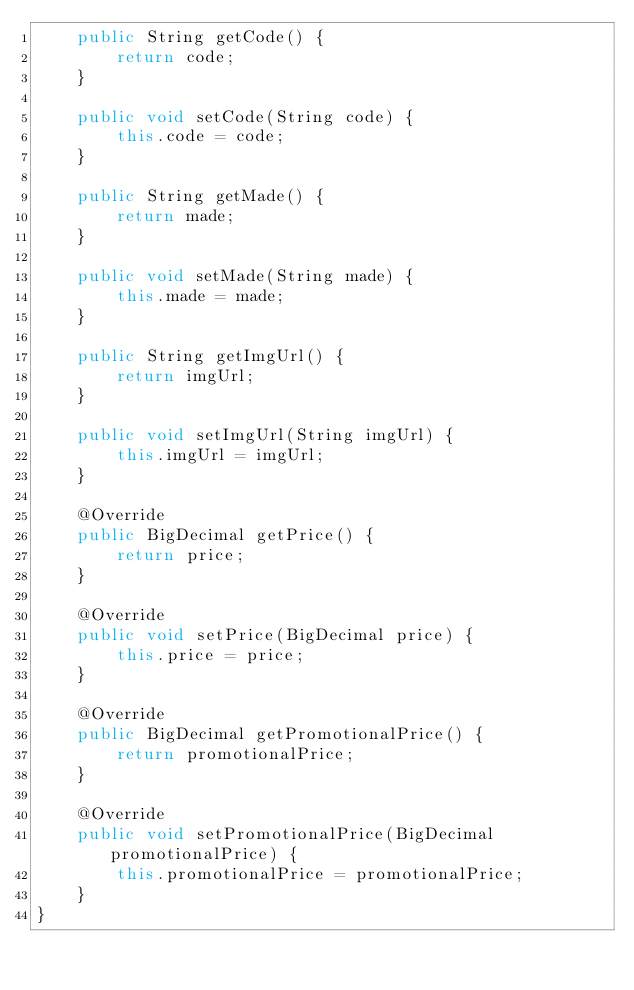<code> <loc_0><loc_0><loc_500><loc_500><_Java_>    public String getCode() {
        return code;
    }

    public void setCode(String code) {
        this.code = code;
    }

    public String getMade() {
        return made;
    }

    public void setMade(String made) {
        this.made = made;
    }

    public String getImgUrl() {
        return imgUrl;
    }

    public void setImgUrl(String imgUrl) {
        this.imgUrl = imgUrl;
    }

    @Override
    public BigDecimal getPrice() {
        return price;
    }

    @Override
    public void setPrice(BigDecimal price) {
        this.price = price;
    }

    @Override
    public BigDecimal getPromotionalPrice() {
        return promotionalPrice;
    }

    @Override
    public void setPromotionalPrice(BigDecimal promotionalPrice) {
        this.promotionalPrice = promotionalPrice;
    }
}
</code> 